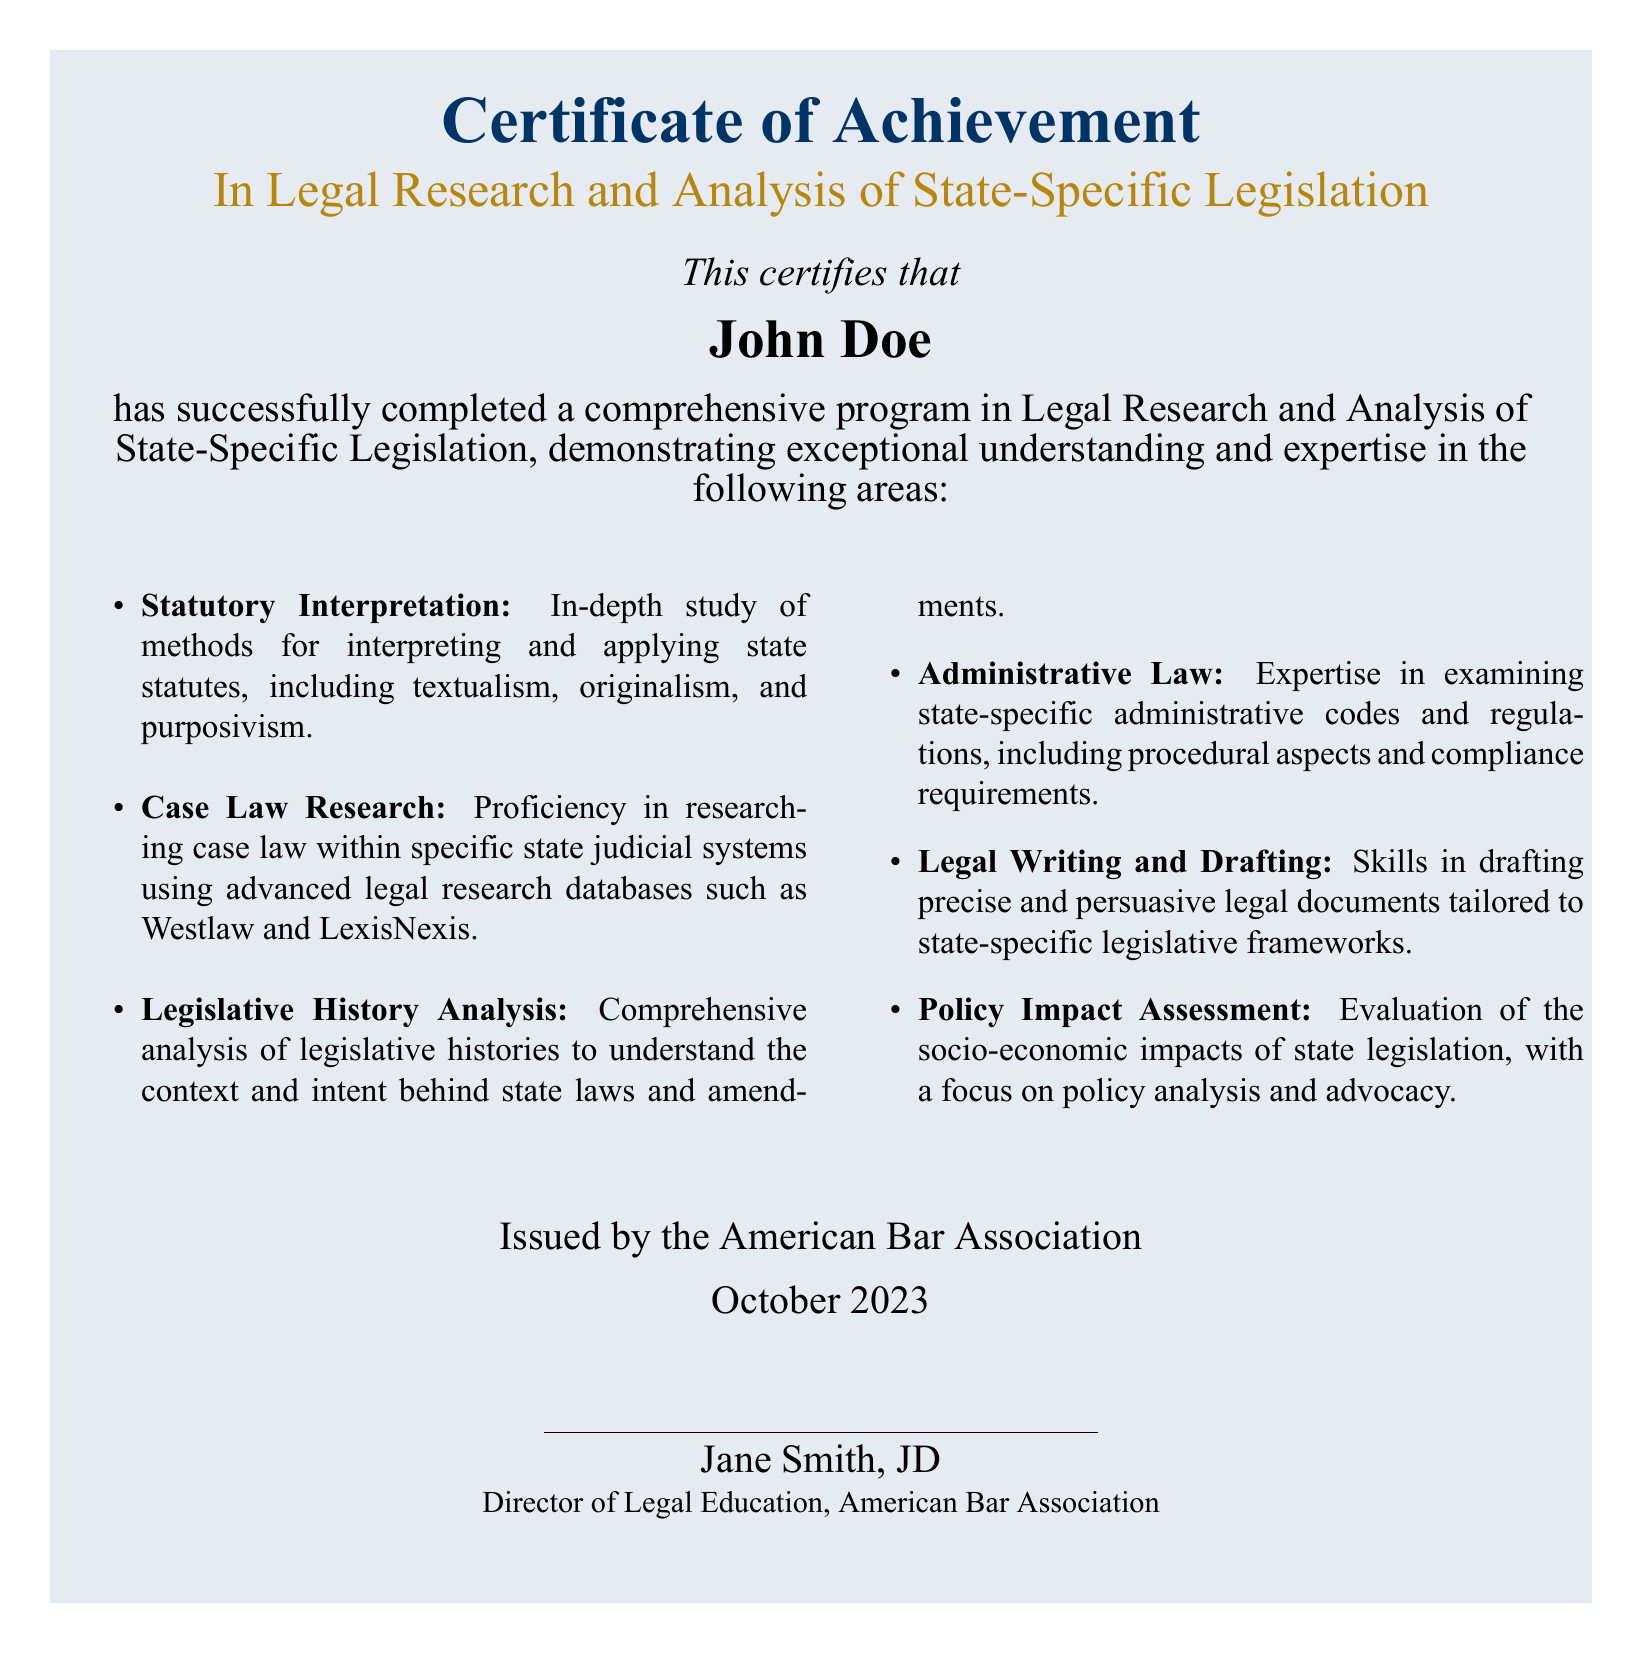What is the title of the certificate? The title of the certificate is stated prominently at the top of the document.
Answer: Certificate of Achievement Who is the recipient of the certificate? The recipient's name is provided below the certificate title.
Answer: John Doe What is the date of issuance of the certificate? The date when the certificate was issued is stated at the bottom of the document.
Answer: October 2023 Who issued the certificate? The issuer of the certificate is mentioned under the date.
Answer: American Bar Association What area of expertise does the certificate focus on? The focus area is specified in the subtitle of the certificate.
Answer: Legal Research and Analysis of State-Specific Legislation How many areas of expertise are listed in the document? The total number of areas listed in the itemized section is calculated from the bulleted points.
Answer: Six What is one method taught in Statutory Interpretation? The methods for interpreting statutes are listed in the relevant section of the document.
Answer: Originalism What title does the issuer hold? The title of the issuer is stated under their name at the end of the document.
Answer: Director of Legal Education What color accent is used in the document? The color accent used in the certificate is mentioned in the design description.
Answer: Gold accent 